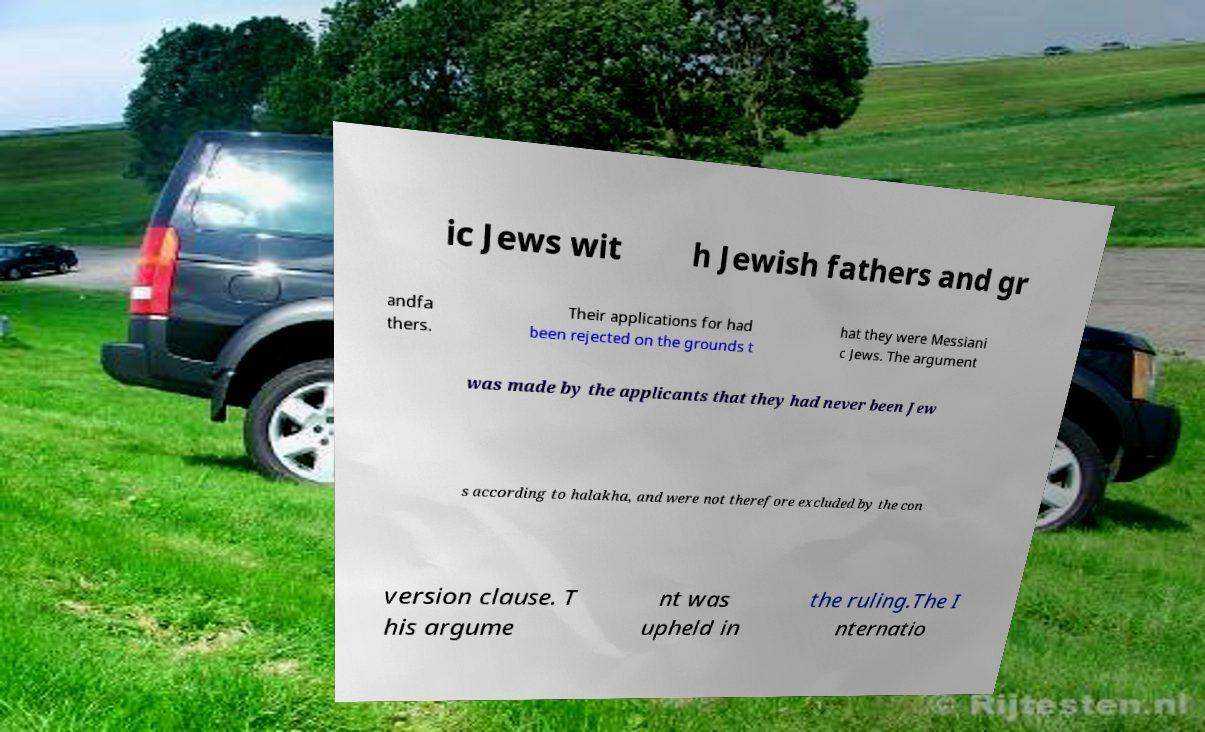Please identify and transcribe the text found in this image. ic Jews wit h Jewish fathers and gr andfa thers. Their applications for had been rejected on the grounds t hat they were Messiani c Jews. The argument was made by the applicants that they had never been Jew s according to halakha, and were not therefore excluded by the con version clause. T his argume nt was upheld in the ruling.The I nternatio 